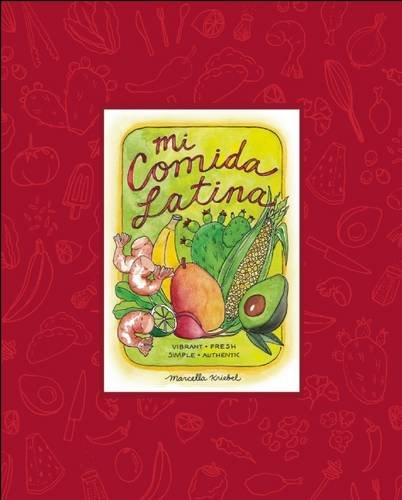Who wrote this book? The book 'Mi Comida Latina' was authored by Marcella Kriebel, who is renowned for her vibrant and visually appealing culinary work focusing on Latin American cuisine. 